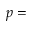<formula> <loc_0><loc_0><loc_500><loc_500>p =</formula> 